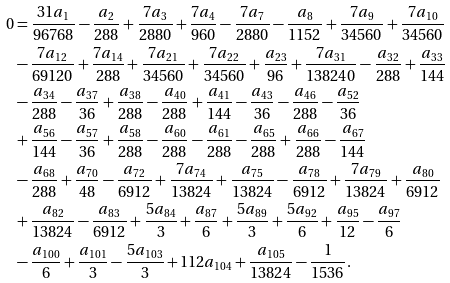Convert formula to latex. <formula><loc_0><loc_0><loc_500><loc_500>0 & = \frac { 3 1 a _ { 1 } } { 9 6 7 6 8 } - \frac { a _ { 2 } } { 2 8 8 } + \frac { 7 a _ { 3 } } { 2 8 8 0 } + \frac { 7 a _ { 4 } } { 9 6 0 } - \frac { 7 a _ { 7 } } { 2 8 8 0 } - \frac { a _ { 8 } } { 1 1 5 2 } + \frac { 7 a _ { 9 } } { 3 4 5 6 0 } + \frac { 7 a _ { 1 0 } } { 3 4 5 6 0 } \\ & - \frac { 7 a _ { 1 2 } } { 6 9 1 2 0 } + \frac { 7 a _ { 1 4 } } { 2 8 8 } + \frac { 7 a _ { 2 1 } } { 3 4 5 6 0 } + \frac { 7 a _ { 2 2 } } { 3 4 5 6 0 } + \frac { a _ { 2 3 } } { 9 6 } + \frac { 7 a _ { 3 1 } } { 1 3 8 2 4 0 } - \frac { a _ { 3 2 } } { 2 8 8 } + \frac { a _ { 3 3 } } { 1 4 4 } \\ & - \frac { a _ { 3 4 } } { 2 8 8 } - \frac { a _ { 3 7 } } { 3 6 } + \frac { a _ { 3 8 } } { 2 8 8 } - \frac { a _ { 4 0 } } { 2 8 8 } + \frac { a _ { 4 1 } } { 1 4 4 } - \frac { a _ { 4 3 } } { 3 6 } - \frac { a _ { 4 6 } } { 2 8 8 } - \frac { a _ { 5 2 } } { 3 6 } \\ & + \frac { a _ { 5 6 } } { 1 4 4 } - \frac { a _ { 5 7 } } { 3 6 } + \frac { a _ { 5 8 } } { 2 8 8 } - \frac { a _ { 6 0 } } { 2 8 8 } - \frac { a _ { 6 1 } } { 2 8 8 } - \frac { a _ { 6 5 } } { 2 8 8 } + \frac { a _ { 6 6 } } { 2 8 8 } - \frac { a _ { 6 7 } } { 1 4 4 } \\ & - \frac { a _ { 6 8 } } { 2 8 8 } + \frac { a _ { 7 0 } } { 4 8 } - \frac { a _ { 7 2 } } { 6 9 1 2 } + \frac { 7 a _ { 7 4 } } { 1 3 8 2 4 } + \frac { a _ { 7 5 } } { 1 3 8 2 4 } - \frac { a _ { 7 8 } } { 6 9 1 2 } + \frac { 7 a _ { 7 9 } } { 1 3 8 2 4 } + \frac { a _ { 8 0 } } { 6 9 1 2 } \\ & + \frac { a _ { 8 2 } } { 1 3 8 2 4 } - \frac { a _ { 8 3 } } { 6 9 1 2 } + \frac { 5 a _ { 8 4 } } { 3 } + \frac { a _ { 8 7 } } { 6 } + \frac { 5 a _ { 8 9 } } { 3 } + \frac { 5 a _ { 9 2 } } { 6 } + \frac { a _ { 9 5 } } { 1 2 } - \frac { a _ { 9 7 } } { 6 } \\ & - \frac { a _ { 1 0 0 } } { 6 } + \frac { a _ { 1 0 1 } } { 3 } - \frac { 5 a _ { 1 0 3 } } { 3 } + 1 1 2 a _ { 1 0 4 } + \frac { a _ { 1 0 5 } } { 1 3 8 2 4 } - \frac { 1 } { 1 5 3 6 } .</formula> 